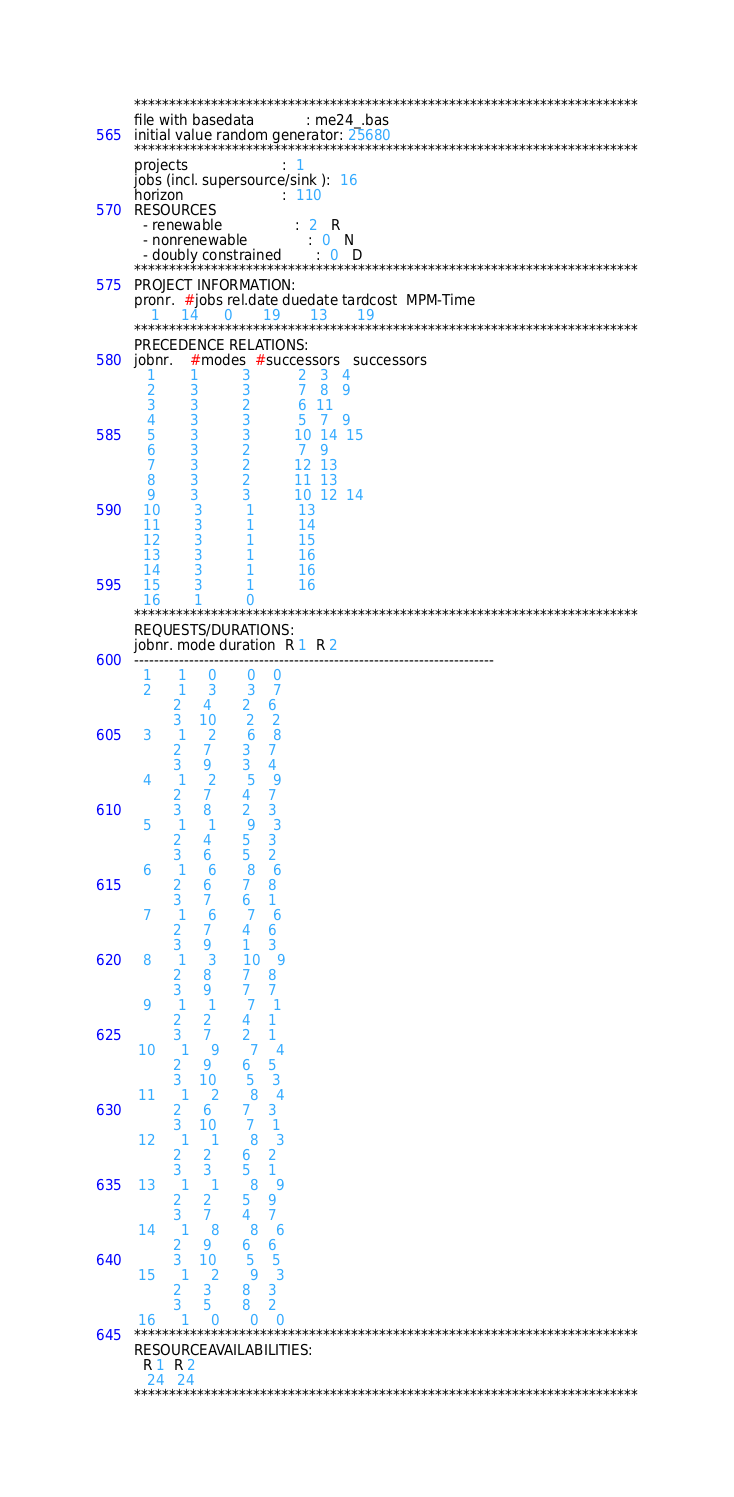Convert code to text. <code><loc_0><loc_0><loc_500><loc_500><_ObjectiveC_>************************************************************************
file with basedata            : me24_.bas
initial value random generator: 25680
************************************************************************
projects                      :  1
jobs (incl. supersource/sink ):  16
horizon                       :  110
RESOURCES
  - renewable                 :  2   R
  - nonrenewable              :  0   N
  - doubly constrained        :  0   D
************************************************************************
PROJECT INFORMATION:
pronr.  #jobs rel.date duedate tardcost  MPM-Time
    1     14      0       19       13       19
************************************************************************
PRECEDENCE RELATIONS:
jobnr.    #modes  #successors   successors
   1        1          3           2   3   4
   2        3          3           7   8   9
   3        3          2           6  11
   4        3          3           5   7   9
   5        3          3          10  14  15
   6        3          2           7   9
   7        3          2          12  13
   8        3          2          11  13
   9        3          3          10  12  14
  10        3          1          13
  11        3          1          14
  12        3          1          15
  13        3          1          16
  14        3          1          16
  15        3          1          16
  16        1          0        
************************************************************************
REQUESTS/DURATIONS:
jobnr. mode duration  R 1  R 2
------------------------------------------------------------------------
  1      1     0       0    0
  2      1     3       3    7
         2     4       2    6
         3    10       2    2
  3      1     2       6    8
         2     7       3    7
         3     9       3    4
  4      1     2       5    9
         2     7       4    7
         3     8       2    3
  5      1     1       9    3
         2     4       5    3
         3     6       5    2
  6      1     6       8    6
         2     6       7    8
         3     7       6    1
  7      1     6       7    6
         2     7       4    6
         3     9       1    3
  8      1     3      10    9
         2     8       7    8
         3     9       7    7
  9      1     1       7    1
         2     2       4    1
         3     7       2    1
 10      1     9       7    4
         2     9       6    5
         3    10       5    3
 11      1     2       8    4
         2     6       7    3
         3    10       7    1
 12      1     1       8    3
         2     2       6    2
         3     3       5    1
 13      1     1       8    9
         2     2       5    9
         3     7       4    7
 14      1     8       8    6
         2     9       6    6
         3    10       5    5
 15      1     2       9    3
         2     3       8    3
         3     5       8    2
 16      1     0       0    0
************************************************************************
RESOURCEAVAILABILITIES:
  R 1  R 2
   24   24
************************************************************************
</code> 